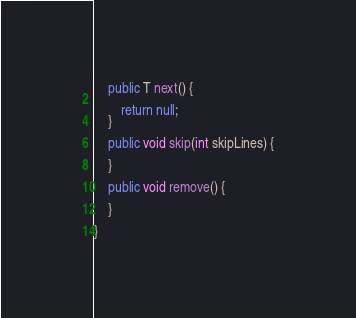Convert code to text. <code><loc_0><loc_0><loc_500><loc_500><_Java_>    public T next() {

        return null;
    }

    public void skip(int skipLines) {

    }

    public void remove() {

    }

}
</code> 